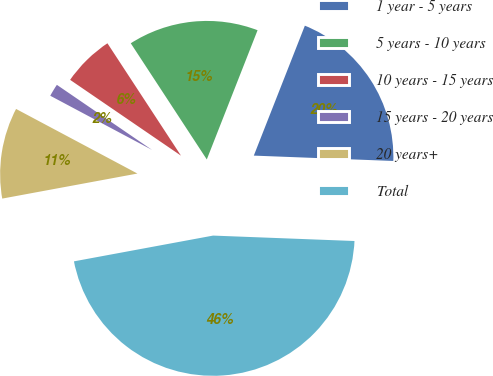Convert chart to OTSL. <chart><loc_0><loc_0><loc_500><loc_500><pie_chart><fcel>1 year - 5 years<fcel>5 years - 10 years<fcel>10 years - 15 years<fcel>15 years - 20 years<fcel>20 years+<fcel>Total<nl><fcel>19.65%<fcel>15.18%<fcel>6.23%<fcel>1.76%<fcel>10.7%<fcel>46.47%<nl></chart> 